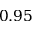Convert formula to latex. <formula><loc_0><loc_0><loc_500><loc_500>0 . 9 5</formula> 